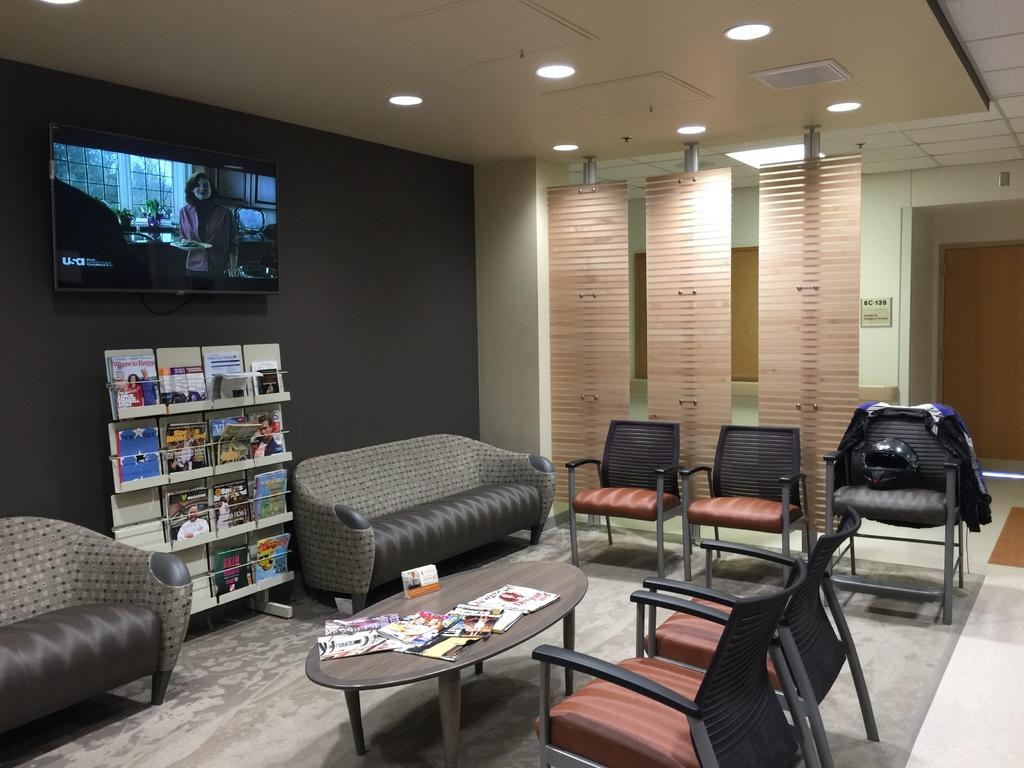What type of furniture is present in the home interior? There is a table, chairs, and couches in the home interior. What can be found on the wall in the home interior? There is a television present on the wall. Where are the lights located in the home interior? The lights are at the top of the room. What type of storage is available for books in the home interior? There is a rack of books in the home interior. How many arches can be seen in the home interior? There are no arches present in the home interior. What type of amphibian is sitting on the couch in the home interior? There are no amphibians, such as toads, present in the home interior. 